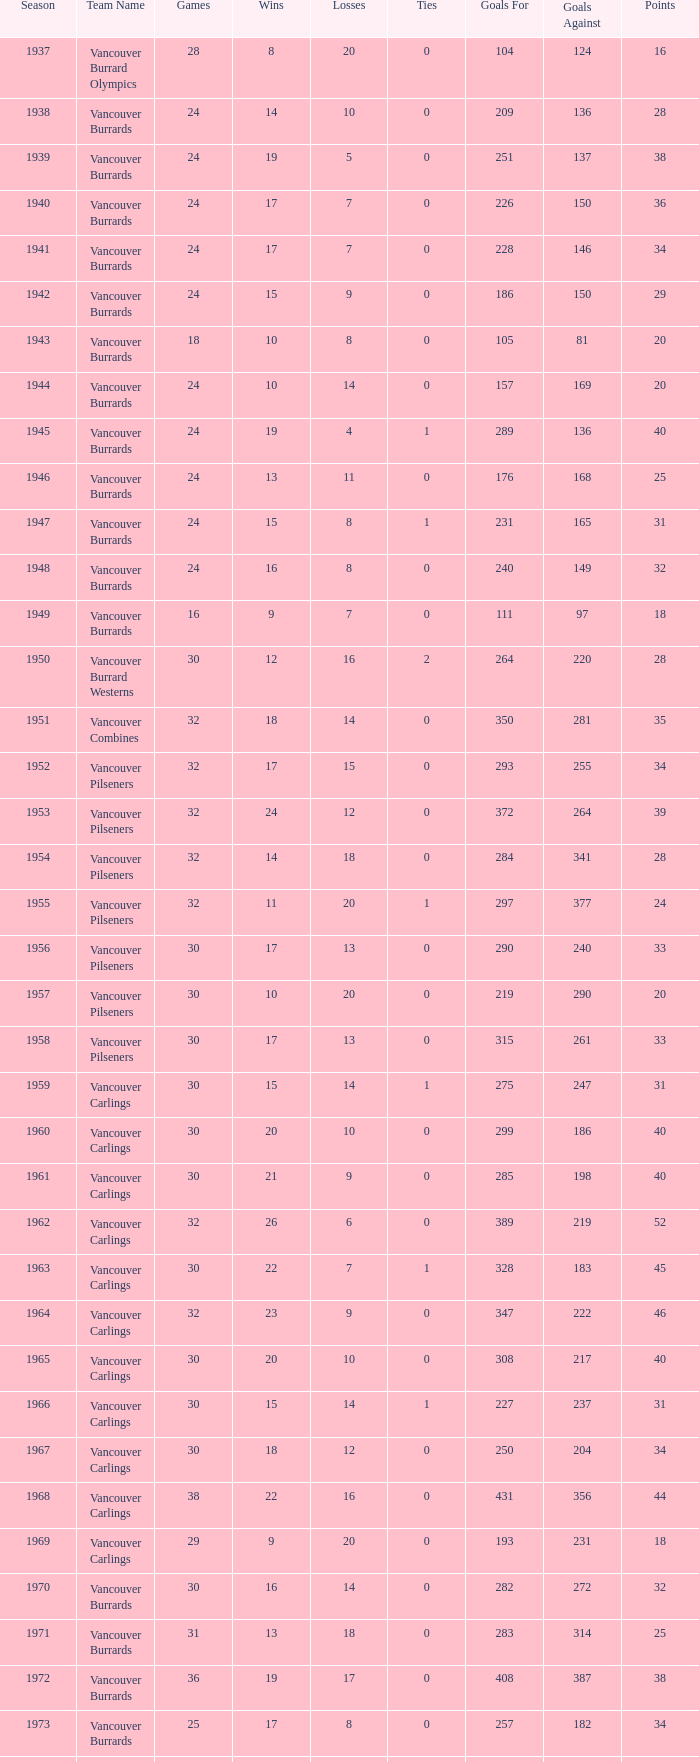Would you mind parsing the complete table? {'header': ['Season', 'Team Name', 'Games', 'Wins', 'Losses', 'Ties', 'Goals For', 'Goals Against', 'Points'], 'rows': [['1937', 'Vancouver Burrard Olympics', '28', '8', '20', '0', '104', '124', '16'], ['1938', 'Vancouver Burrards', '24', '14', '10', '0', '209', '136', '28'], ['1939', 'Vancouver Burrards', '24', '19', '5', '0', '251', '137', '38'], ['1940', 'Vancouver Burrards', '24', '17', '7', '0', '226', '150', '36'], ['1941', 'Vancouver Burrards', '24', '17', '7', '0', '228', '146', '34'], ['1942', 'Vancouver Burrards', '24', '15', '9', '0', '186', '150', '29'], ['1943', 'Vancouver Burrards', '18', '10', '8', '0', '105', '81', '20'], ['1944', 'Vancouver Burrards', '24', '10', '14', '0', '157', '169', '20'], ['1945', 'Vancouver Burrards', '24', '19', '4', '1', '289', '136', '40'], ['1946', 'Vancouver Burrards', '24', '13', '11', '0', '176', '168', '25'], ['1947', 'Vancouver Burrards', '24', '15', '8', '1', '231', '165', '31'], ['1948', 'Vancouver Burrards', '24', '16', '8', '0', '240', '149', '32'], ['1949', 'Vancouver Burrards', '16', '9', '7', '0', '111', '97', '18'], ['1950', 'Vancouver Burrard Westerns', '30', '12', '16', '2', '264', '220', '28'], ['1951', 'Vancouver Combines', '32', '18', '14', '0', '350', '281', '35'], ['1952', 'Vancouver Pilseners', '32', '17', '15', '0', '293', '255', '34'], ['1953', 'Vancouver Pilseners', '32', '24', '12', '0', '372', '264', '39'], ['1954', 'Vancouver Pilseners', '32', '14', '18', '0', '284', '341', '28'], ['1955', 'Vancouver Pilseners', '32', '11', '20', '1', '297', '377', '24'], ['1956', 'Vancouver Pilseners', '30', '17', '13', '0', '290', '240', '33'], ['1957', 'Vancouver Pilseners', '30', '10', '20', '0', '219', '290', '20'], ['1958', 'Vancouver Pilseners', '30', '17', '13', '0', '315', '261', '33'], ['1959', 'Vancouver Carlings', '30', '15', '14', '1', '275', '247', '31'], ['1960', 'Vancouver Carlings', '30', '20', '10', '0', '299', '186', '40'], ['1961', 'Vancouver Carlings', '30', '21', '9', '0', '285', '198', '40'], ['1962', 'Vancouver Carlings', '32', '26', '6', '0', '389', '219', '52'], ['1963', 'Vancouver Carlings', '30', '22', '7', '1', '328', '183', '45'], ['1964', 'Vancouver Carlings', '32', '23', '9', '0', '347', '222', '46'], ['1965', 'Vancouver Carlings', '30', '20', '10', '0', '308', '217', '40'], ['1966', 'Vancouver Carlings', '30', '15', '14', '1', '227', '237', '31'], ['1967', 'Vancouver Carlings', '30', '18', '12', '0', '250', '204', '34'], ['1968', 'Vancouver Carlings', '38', '22', '16', '0', '431', '356', '44'], ['1969', 'Vancouver Carlings', '29', '9', '20', '0', '193', '231', '18'], ['1970', 'Vancouver Burrards', '30', '16', '14', '0', '282', '272', '32'], ['1971', 'Vancouver Burrards', '31', '13', '18', '0', '283', '314', '25'], ['1972', 'Vancouver Burrards', '36', '19', '17', '0', '408', '387', '38'], ['1973', 'Vancouver Burrards', '25', '17', '8', '0', '257', '182', '34'], ['1974', 'Vancouver Burrards', '24', '11', '13', '0', '219', '232', '22'], ['1975', 'Vancouver Burrards', '24', '14', '10', '0', '209', '187', '28'], ['1976', 'Vancouver Burrards', '24', '10', '14', '0', '182', '205', '20'], ['1977', 'Vancouver Burrards', '24', '17', '7', '0', '240', '184', '33'], ['1978', 'Vancouver Burrards', '24', '11', '13', '0', '194', '223', '22'], ['1979', 'Vancouver Burrards', '30', '11', '19', '0', '228', '283', '22'], ['1980', 'Vancouver Burrards', '24', '11', '13', '0', '177', '195', '22'], ['1981', 'Vancouver Burrards', '24', '12', '12', '0', '192', '183', '24'], ['1982', 'Vancouver Burrards', '24', '12', '12', '0', '202', '201', '24'], ['1983', 'Vancouver Burrards', '24', '14', '10', '0', '217', '194', '28'], ['1984', 'Vancouver Burrards', '24', '9', '15', '0', '181', '205', '18'], ['1985', 'Vancouver Burrards', '24', '11', '13', '0', '179', '191', '22'], ['1986', 'Vancouver Burrards', '24', '14', '11', '0', '203', '177', '26'], ['1987', 'Vancouver Burrards', '24', '10', '14', '0', '203', '220', '20'], ['1988', 'Vancouver Burrards', '24', '11', '13', '0', '195', '180', '22'], ['1989', 'Vancouver Burrards', '24', '9', '15', '0', '201', '227', '18'], ['1990', 'Vancouver Burrards', '24', '16', '8', '0', '264', '192', '32'], ['1991', 'Vancouver Burrards', '24', '8', '16', '0', '201', '225', '16'], ['1992', 'Vancouver Burrards', '24', '9', '15', '0', '157', '186', '18'], ['1993', 'Vancouver Burrards', '24', '3', '20', '1', '132', '218', '8'], ['1994', 'Surrey Burrards', '20', '8', '12', '0', '162', '196', '16'], ['1995', 'Surrey Burrards', '25', '6', '19', '0', '216', '319', '11'], ['1996', 'Maple Ridge Burrards', '20', '15', '8', '0', '211', '150', '23'], ['1997', 'Maple Ridge Burrards', '20', '11', '8', '0', '180', '158', '23'], ['1998', 'Maple Ridge Burrards', '25', '24', '8', '0', '305', '179', '32'], ['1999', 'Maple Ridge Burrards', '25', '5', '15', '5', '212', '225', '20'], ['2000', 'Maple Ridge Burrards', '25', '4', '16', '5', '175', '224', '18'], ['2001', 'Maple Ridge Burrards', '20', '3', '16', '1', '120', '170', '8'], ['2002', 'Maple Ridge Burrards', '20', '4', '15', '1', '132', '186', '8'], ['2003', 'Maple Ridge Burrards', '20', '5', '15', '1', '149', '179', '10'], ['2004', 'Maple Ridge Burrards', '20', '8', '12', '0', '159', '156', '16'], ['2005', 'Maple Ridge Burrards', '18', '10', '8', '0', '156', '136', '19'], ['2006', 'Maple Ridge Burrards', '18', '7', '11', '0', '143', '153', '14'], ['2007', 'Maple Ridge Burrards', '18', '7', '11', '0', '156', '182', '14'], ['2008', 'Maple Ridge Burrards', '18', '5', '13', '0', '137', '150', '10'], ['2009', 'Maple Ridge Burrards', '18', '7', '11', '0', '144', '162', '14'], ['2010', 'Maple Ridge Burrards', '18', '9', '9', '0', '149', '136', '18'], ['Total', '74 seasons', '1,879', '913', '913', '1,916', '14,845', '13,929', '1,916']]} What's the total number of games with more than 20 points for the 1976 season? 0.0. 